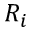<formula> <loc_0><loc_0><loc_500><loc_500>R _ { i }</formula> 